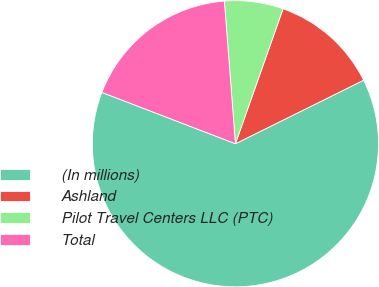Convert chart to OTSL. <chart><loc_0><loc_0><loc_500><loc_500><pie_chart><fcel>(In millions)<fcel>Ashland<fcel>Pilot Travel Centers LLC (PTC)<fcel>Total<nl><fcel>63.16%<fcel>12.28%<fcel>6.63%<fcel>17.93%<nl></chart> 